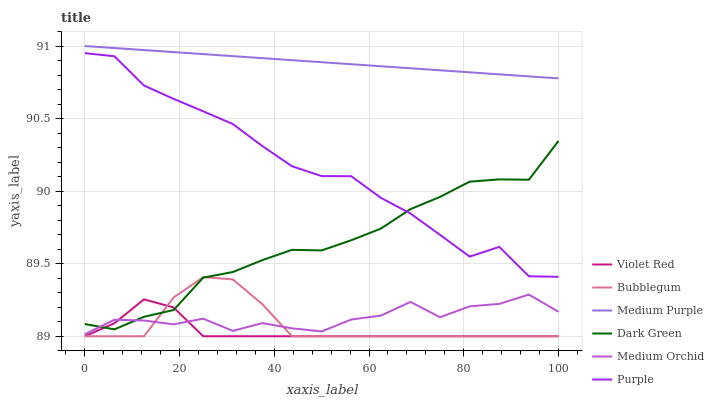Does Violet Red have the minimum area under the curve?
Answer yes or no. Yes. Does Medium Purple have the maximum area under the curve?
Answer yes or no. Yes. Does Purple have the minimum area under the curve?
Answer yes or no. No. Does Purple have the maximum area under the curve?
Answer yes or no. No. Is Medium Purple the smoothest?
Answer yes or no. Yes. Is Medium Orchid the roughest?
Answer yes or no. Yes. Is Purple the smoothest?
Answer yes or no. No. Is Purple the roughest?
Answer yes or no. No. Does Violet Red have the lowest value?
Answer yes or no. Yes. Does Purple have the lowest value?
Answer yes or no. No. Does Medium Purple have the highest value?
Answer yes or no. Yes. Does Purple have the highest value?
Answer yes or no. No. Is Medium Orchid less than Purple?
Answer yes or no. Yes. Is Medium Purple greater than Violet Red?
Answer yes or no. Yes. Does Purple intersect Dark Green?
Answer yes or no. Yes. Is Purple less than Dark Green?
Answer yes or no. No. Is Purple greater than Dark Green?
Answer yes or no. No. Does Medium Orchid intersect Purple?
Answer yes or no. No. 